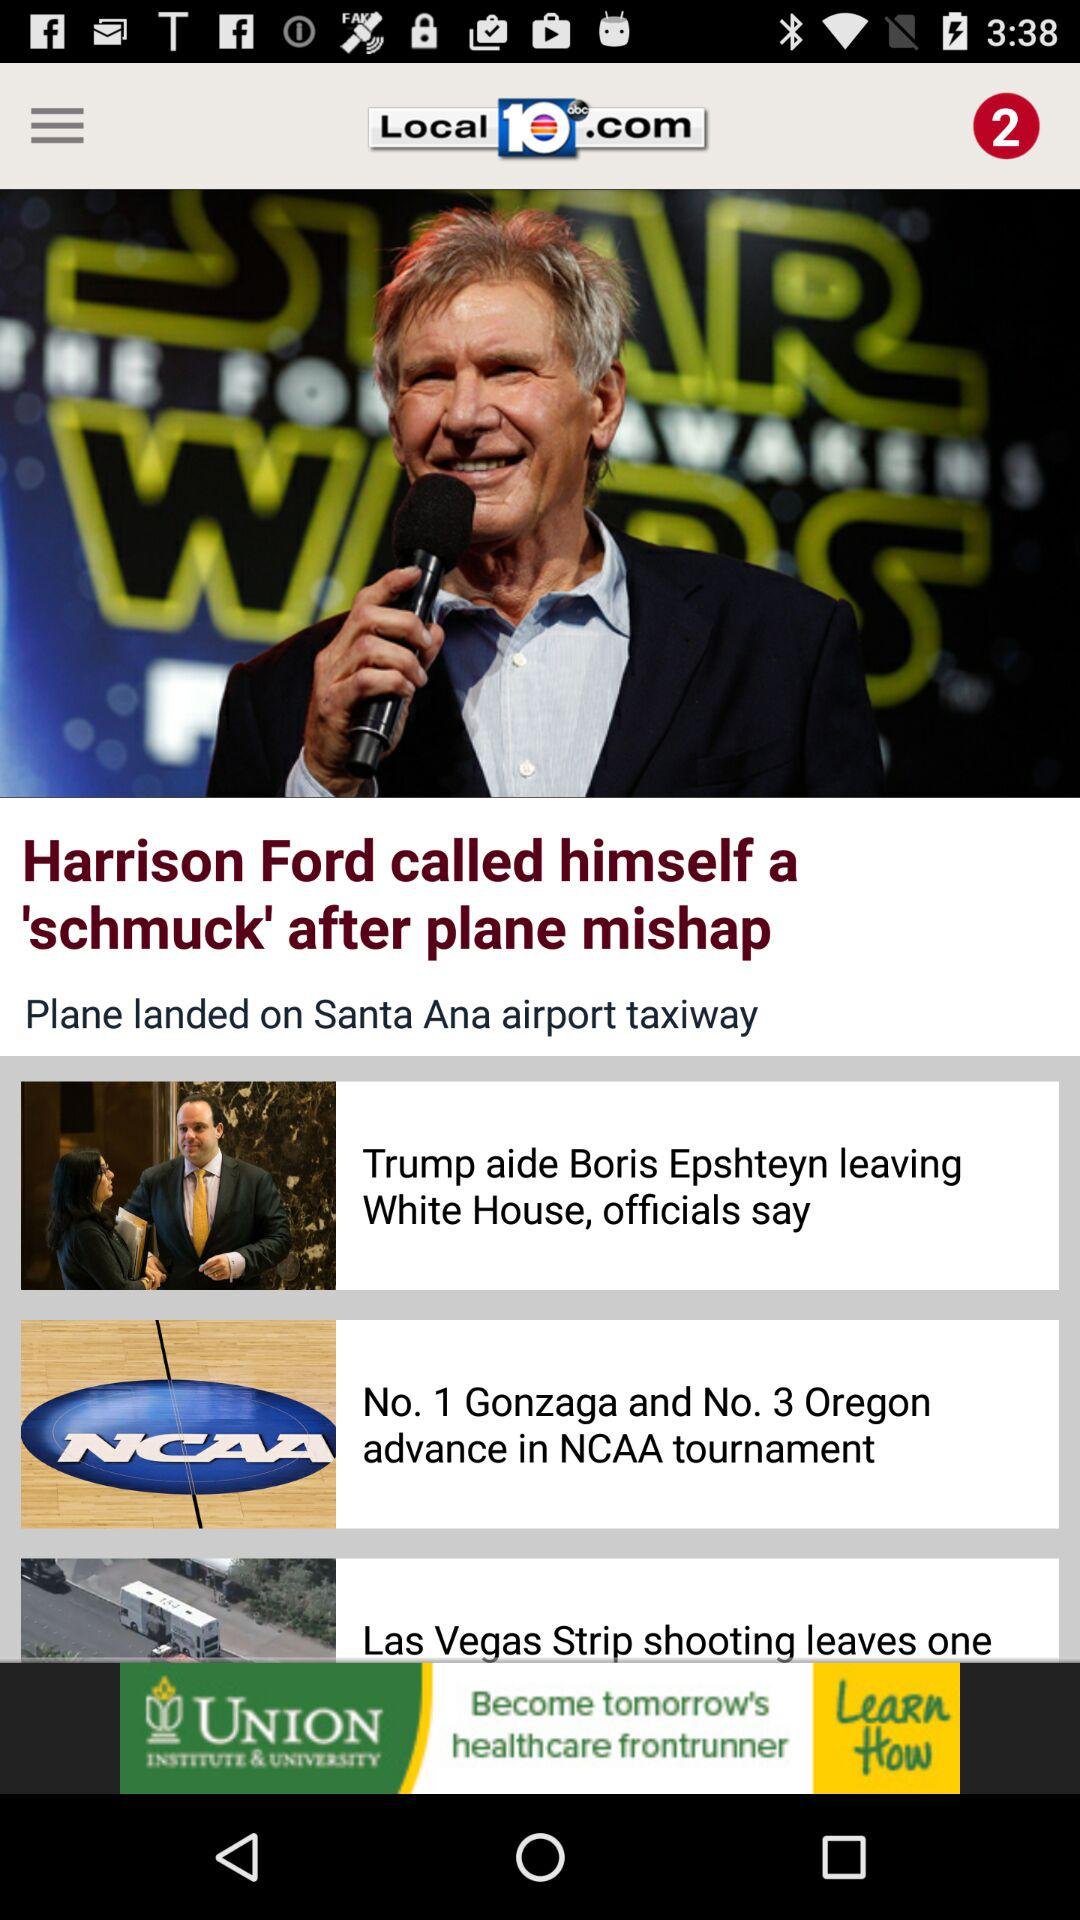What is the news title? The news titles are "Harrison Ford called himself a 'schmuck' after plane mishap", "Trump aide Boris Epshteyn leaving White House, officials say" and "No. 1 Gonzaga and No. 3 Oregon advance in NCAA tournament". 